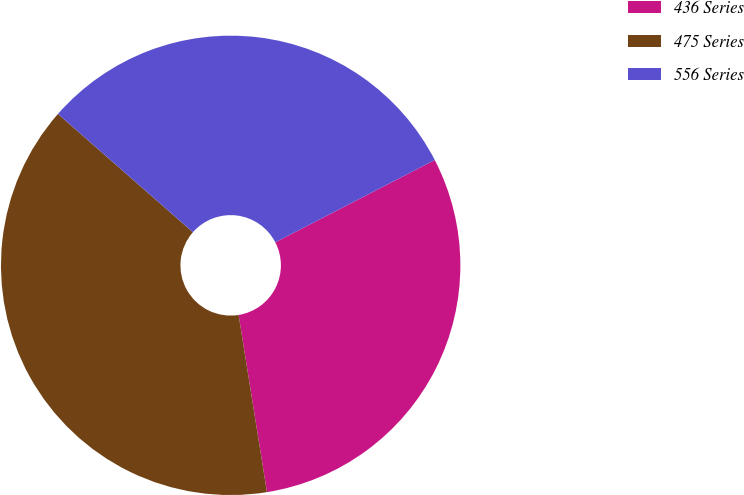Convert chart to OTSL. <chart><loc_0><loc_0><loc_500><loc_500><pie_chart><fcel>436 Series<fcel>475 Series<fcel>556 Series<nl><fcel>30.06%<fcel>38.98%<fcel>30.96%<nl></chart> 